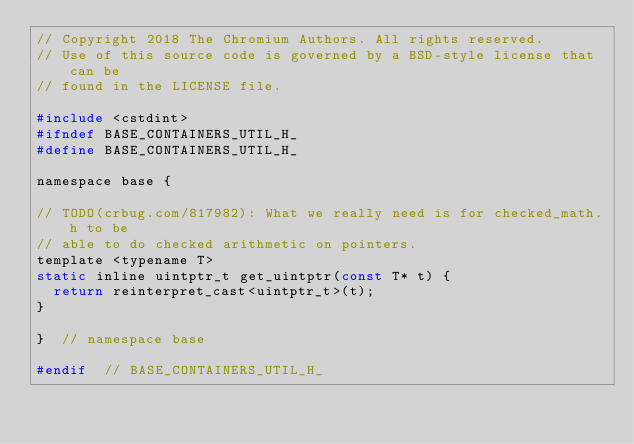<code> <loc_0><loc_0><loc_500><loc_500><_C_>// Copyright 2018 The Chromium Authors. All rights reserved.
// Use of this source code is governed by a BSD-style license that can be
// found in the LICENSE file.

#include <cstdint>
#ifndef BASE_CONTAINERS_UTIL_H_
#define BASE_CONTAINERS_UTIL_H_

namespace base {

// TODO(crbug.com/817982): What we really need is for checked_math.h to be
// able to do checked arithmetic on pointers.
template <typename T>
static inline uintptr_t get_uintptr(const T* t) {
  return reinterpret_cast<uintptr_t>(t);
}

}  // namespace base

#endif  // BASE_CONTAINERS_UTIL_H_
</code> 